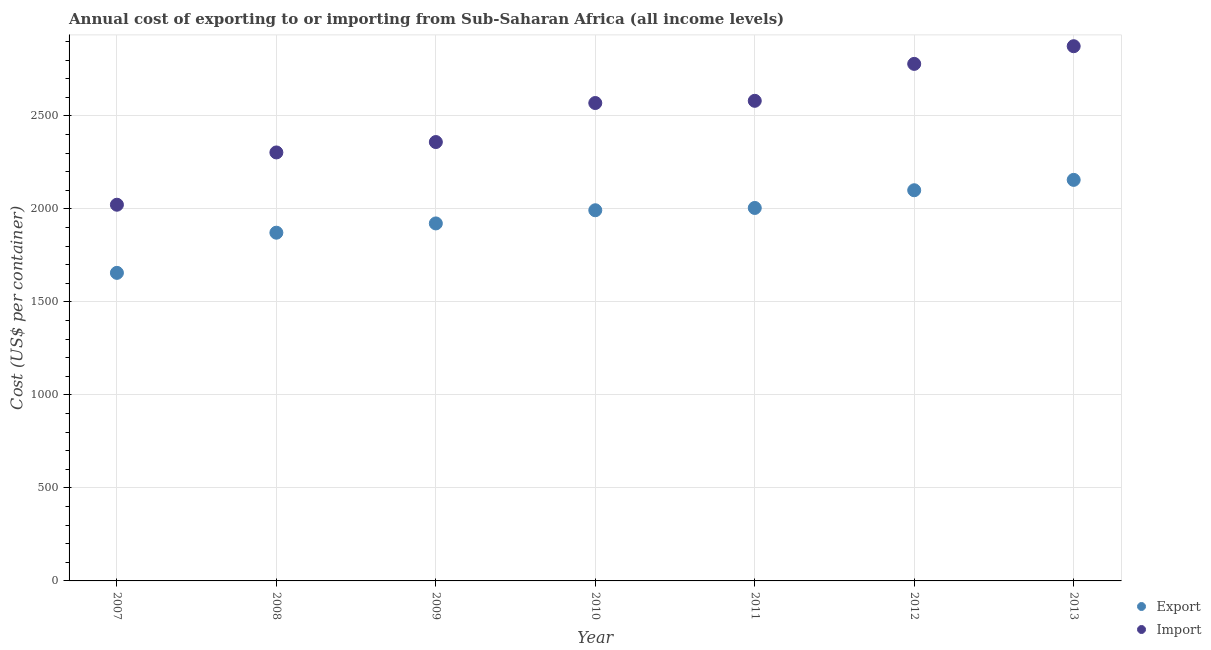Is the number of dotlines equal to the number of legend labels?
Your answer should be compact. Yes. What is the export cost in 2007?
Your response must be concise. 1655.89. Across all years, what is the maximum import cost?
Provide a succinct answer. 2874.2. Across all years, what is the minimum export cost?
Ensure brevity in your answer.  1655.89. In which year was the export cost maximum?
Offer a very short reply. 2013. What is the total import cost in the graph?
Your answer should be compact. 1.75e+04. What is the difference between the export cost in 2007 and that in 2012?
Give a very brief answer. -444.07. What is the difference between the export cost in 2007 and the import cost in 2012?
Keep it short and to the point. -1123.3. What is the average export cost per year?
Offer a very short reply. 1957.45. In the year 2012, what is the difference between the import cost and export cost?
Give a very brief answer. 679.23. What is the ratio of the import cost in 2007 to that in 2009?
Offer a terse response. 0.86. Is the export cost in 2010 less than that in 2012?
Your answer should be compact. Yes. What is the difference between the highest and the second highest export cost?
Make the answer very short. 55.74. What is the difference between the highest and the lowest import cost?
Your response must be concise. 852.07. In how many years, is the export cost greater than the average export cost taken over all years?
Offer a very short reply. 4. How many dotlines are there?
Provide a succinct answer. 2. What is the difference between two consecutive major ticks on the Y-axis?
Your answer should be compact. 500. Are the values on the major ticks of Y-axis written in scientific E-notation?
Ensure brevity in your answer.  No. How many legend labels are there?
Provide a succinct answer. 2. How are the legend labels stacked?
Provide a succinct answer. Vertical. What is the title of the graph?
Offer a very short reply. Annual cost of exporting to or importing from Sub-Saharan Africa (all income levels). What is the label or title of the Y-axis?
Your answer should be very brief. Cost (US$ per container). What is the Cost (US$ per container) in Export in 2007?
Ensure brevity in your answer.  1655.89. What is the Cost (US$ per container) in Import in 2007?
Keep it short and to the point. 2022.13. What is the Cost (US$ per container) of Export in 2008?
Make the answer very short. 1871.78. What is the Cost (US$ per container) of Import in 2008?
Provide a short and direct response. 2303.17. What is the Cost (US$ per container) of Export in 2009?
Provide a short and direct response. 1921.63. What is the Cost (US$ per container) of Import in 2009?
Ensure brevity in your answer.  2359.07. What is the Cost (US$ per container) of Export in 2010?
Your response must be concise. 1992.41. What is the Cost (US$ per container) in Import in 2010?
Offer a terse response. 2568.83. What is the Cost (US$ per container) in Export in 2011?
Your response must be concise. 2004.76. What is the Cost (US$ per container) of Import in 2011?
Offer a very short reply. 2580.65. What is the Cost (US$ per container) in Export in 2012?
Your answer should be compact. 2099.96. What is the Cost (US$ per container) of Import in 2012?
Give a very brief answer. 2779.19. What is the Cost (US$ per container) in Export in 2013?
Your answer should be compact. 2155.7. What is the Cost (US$ per container) of Import in 2013?
Ensure brevity in your answer.  2874.2. Across all years, what is the maximum Cost (US$ per container) of Export?
Give a very brief answer. 2155.7. Across all years, what is the maximum Cost (US$ per container) in Import?
Ensure brevity in your answer.  2874.2. Across all years, what is the minimum Cost (US$ per container) of Export?
Your answer should be compact. 1655.89. Across all years, what is the minimum Cost (US$ per container) of Import?
Your answer should be very brief. 2022.13. What is the total Cost (US$ per container) of Export in the graph?
Your response must be concise. 1.37e+04. What is the total Cost (US$ per container) of Import in the graph?
Your answer should be very brief. 1.75e+04. What is the difference between the Cost (US$ per container) in Export in 2007 and that in 2008?
Make the answer very short. -215.89. What is the difference between the Cost (US$ per container) in Import in 2007 and that in 2008?
Provide a short and direct response. -281.04. What is the difference between the Cost (US$ per container) in Export in 2007 and that in 2009?
Provide a short and direct response. -265.74. What is the difference between the Cost (US$ per container) of Import in 2007 and that in 2009?
Keep it short and to the point. -336.93. What is the difference between the Cost (US$ per container) of Export in 2007 and that in 2010?
Ensure brevity in your answer.  -336.52. What is the difference between the Cost (US$ per container) in Import in 2007 and that in 2010?
Give a very brief answer. -546.7. What is the difference between the Cost (US$ per container) of Export in 2007 and that in 2011?
Provide a succinct answer. -348.87. What is the difference between the Cost (US$ per container) of Import in 2007 and that in 2011?
Keep it short and to the point. -558.52. What is the difference between the Cost (US$ per container) in Export in 2007 and that in 2012?
Give a very brief answer. -444.07. What is the difference between the Cost (US$ per container) of Import in 2007 and that in 2012?
Give a very brief answer. -757.06. What is the difference between the Cost (US$ per container) in Export in 2007 and that in 2013?
Offer a very short reply. -499.81. What is the difference between the Cost (US$ per container) in Import in 2007 and that in 2013?
Your response must be concise. -852.07. What is the difference between the Cost (US$ per container) in Export in 2008 and that in 2009?
Give a very brief answer. -49.85. What is the difference between the Cost (US$ per container) in Import in 2008 and that in 2009?
Your answer should be very brief. -55.89. What is the difference between the Cost (US$ per container) in Export in 2008 and that in 2010?
Give a very brief answer. -120.63. What is the difference between the Cost (US$ per container) of Import in 2008 and that in 2010?
Offer a very short reply. -265.65. What is the difference between the Cost (US$ per container) in Export in 2008 and that in 2011?
Offer a very short reply. -132.98. What is the difference between the Cost (US$ per container) of Import in 2008 and that in 2011?
Ensure brevity in your answer.  -277.48. What is the difference between the Cost (US$ per container) of Export in 2008 and that in 2012?
Provide a short and direct response. -228.17. What is the difference between the Cost (US$ per container) of Import in 2008 and that in 2012?
Offer a very short reply. -476.02. What is the difference between the Cost (US$ per container) of Export in 2008 and that in 2013?
Provide a succinct answer. -283.92. What is the difference between the Cost (US$ per container) in Import in 2008 and that in 2013?
Your answer should be compact. -571.03. What is the difference between the Cost (US$ per container) of Export in 2009 and that in 2010?
Give a very brief answer. -70.78. What is the difference between the Cost (US$ per container) of Import in 2009 and that in 2010?
Offer a very short reply. -209.76. What is the difference between the Cost (US$ per container) of Export in 2009 and that in 2011?
Your answer should be compact. -83.13. What is the difference between the Cost (US$ per container) of Import in 2009 and that in 2011?
Provide a short and direct response. -221.59. What is the difference between the Cost (US$ per container) of Export in 2009 and that in 2012?
Make the answer very short. -178.33. What is the difference between the Cost (US$ per container) of Import in 2009 and that in 2012?
Your response must be concise. -420.13. What is the difference between the Cost (US$ per container) of Export in 2009 and that in 2013?
Offer a terse response. -234.07. What is the difference between the Cost (US$ per container) in Import in 2009 and that in 2013?
Give a very brief answer. -515.14. What is the difference between the Cost (US$ per container) of Export in 2010 and that in 2011?
Give a very brief answer. -12.35. What is the difference between the Cost (US$ per container) in Import in 2010 and that in 2011?
Keep it short and to the point. -11.83. What is the difference between the Cost (US$ per container) in Export in 2010 and that in 2012?
Your answer should be very brief. -107.54. What is the difference between the Cost (US$ per container) of Import in 2010 and that in 2012?
Offer a very short reply. -210.37. What is the difference between the Cost (US$ per container) of Export in 2010 and that in 2013?
Provide a short and direct response. -163.29. What is the difference between the Cost (US$ per container) of Import in 2010 and that in 2013?
Provide a succinct answer. -305.38. What is the difference between the Cost (US$ per container) of Export in 2011 and that in 2012?
Offer a terse response. -95.2. What is the difference between the Cost (US$ per container) of Import in 2011 and that in 2012?
Keep it short and to the point. -198.54. What is the difference between the Cost (US$ per container) of Export in 2011 and that in 2013?
Your answer should be compact. -150.94. What is the difference between the Cost (US$ per container) of Import in 2011 and that in 2013?
Make the answer very short. -293.55. What is the difference between the Cost (US$ per container) of Export in 2012 and that in 2013?
Your answer should be very brief. -55.74. What is the difference between the Cost (US$ per container) of Import in 2012 and that in 2013?
Your answer should be very brief. -95.01. What is the difference between the Cost (US$ per container) of Export in 2007 and the Cost (US$ per container) of Import in 2008?
Your answer should be very brief. -647.28. What is the difference between the Cost (US$ per container) of Export in 2007 and the Cost (US$ per container) of Import in 2009?
Your response must be concise. -703.17. What is the difference between the Cost (US$ per container) in Export in 2007 and the Cost (US$ per container) in Import in 2010?
Keep it short and to the point. -912.93. What is the difference between the Cost (US$ per container) of Export in 2007 and the Cost (US$ per container) of Import in 2011?
Provide a short and direct response. -924.76. What is the difference between the Cost (US$ per container) in Export in 2007 and the Cost (US$ per container) in Import in 2012?
Your answer should be compact. -1123.3. What is the difference between the Cost (US$ per container) in Export in 2007 and the Cost (US$ per container) in Import in 2013?
Give a very brief answer. -1218.31. What is the difference between the Cost (US$ per container) in Export in 2008 and the Cost (US$ per container) in Import in 2009?
Offer a terse response. -487.28. What is the difference between the Cost (US$ per container) of Export in 2008 and the Cost (US$ per container) of Import in 2010?
Offer a very short reply. -697.04. What is the difference between the Cost (US$ per container) of Export in 2008 and the Cost (US$ per container) of Import in 2011?
Your response must be concise. -708.87. What is the difference between the Cost (US$ per container) in Export in 2008 and the Cost (US$ per container) in Import in 2012?
Make the answer very short. -907.41. What is the difference between the Cost (US$ per container) in Export in 2008 and the Cost (US$ per container) in Import in 2013?
Your answer should be very brief. -1002.42. What is the difference between the Cost (US$ per container) of Export in 2009 and the Cost (US$ per container) of Import in 2010?
Your answer should be very brief. -647.2. What is the difference between the Cost (US$ per container) in Export in 2009 and the Cost (US$ per container) in Import in 2011?
Your answer should be very brief. -659.02. What is the difference between the Cost (US$ per container) of Export in 2009 and the Cost (US$ per container) of Import in 2012?
Your response must be concise. -857.56. What is the difference between the Cost (US$ per container) in Export in 2009 and the Cost (US$ per container) in Import in 2013?
Ensure brevity in your answer.  -952.57. What is the difference between the Cost (US$ per container) of Export in 2010 and the Cost (US$ per container) of Import in 2011?
Make the answer very short. -588.24. What is the difference between the Cost (US$ per container) of Export in 2010 and the Cost (US$ per container) of Import in 2012?
Keep it short and to the point. -786.78. What is the difference between the Cost (US$ per container) in Export in 2010 and the Cost (US$ per container) in Import in 2013?
Make the answer very short. -881.79. What is the difference between the Cost (US$ per container) of Export in 2011 and the Cost (US$ per container) of Import in 2012?
Offer a very short reply. -774.43. What is the difference between the Cost (US$ per container) in Export in 2011 and the Cost (US$ per container) in Import in 2013?
Give a very brief answer. -869.44. What is the difference between the Cost (US$ per container) in Export in 2012 and the Cost (US$ per container) in Import in 2013?
Your answer should be compact. -774.24. What is the average Cost (US$ per container) in Export per year?
Your answer should be very brief. 1957.45. What is the average Cost (US$ per container) in Import per year?
Keep it short and to the point. 2498.18. In the year 2007, what is the difference between the Cost (US$ per container) of Export and Cost (US$ per container) of Import?
Your response must be concise. -366.24. In the year 2008, what is the difference between the Cost (US$ per container) of Export and Cost (US$ per container) of Import?
Your answer should be very brief. -431.39. In the year 2009, what is the difference between the Cost (US$ per container) in Export and Cost (US$ per container) in Import?
Keep it short and to the point. -437.43. In the year 2010, what is the difference between the Cost (US$ per container) in Export and Cost (US$ per container) in Import?
Provide a succinct answer. -576.41. In the year 2011, what is the difference between the Cost (US$ per container) in Export and Cost (US$ per container) in Import?
Your answer should be very brief. -575.89. In the year 2012, what is the difference between the Cost (US$ per container) of Export and Cost (US$ per container) of Import?
Make the answer very short. -679.23. In the year 2013, what is the difference between the Cost (US$ per container) of Export and Cost (US$ per container) of Import?
Offer a terse response. -718.5. What is the ratio of the Cost (US$ per container) of Export in 2007 to that in 2008?
Keep it short and to the point. 0.88. What is the ratio of the Cost (US$ per container) of Import in 2007 to that in 2008?
Give a very brief answer. 0.88. What is the ratio of the Cost (US$ per container) in Export in 2007 to that in 2009?
Offer a terse response. 0.86. What is the ratio of the Cost (US$ per container) of Import in 2007 to that in 2009?
Provide a succinct answer. 0.86. What is the ratio of the Cost (US$ per container) of Export in 2007 to that in 2010?
Your response must be concise. 0.83. What is the ratio of the Cost (US$ per container) in Import in 2007 to that in 2010?
Ensure brevity in your answer.  0.79. What is the ratio of the Cost (US$ per container) in Export in 2007 to that in 2011?
Offer a very short reply. 0.83. What is the ratio of the Cost (US$ per container) in Import in 2007 to that in 2011?
Keep it short and to the point. 0.78. What is the ratio of the Cost (US$ per container) of Export in 2007 to that in 2012?
Your answer should be very brief. 0.79. What is the ratio of the Cost (US$ per container) in Import in 2007 to that in 2012?
Give a very brief answer. 0.73. What is the ratio of the Cost (US$ per container) of Export in 2007 to that in 2013?
Provide a short and direct response. 0.77. What is the ratio of the Cost (US$ per container) of Import in 2007 to that in 2013?
Keep it short and to the point. 0.7. What is the ratio of the Cost (US$ per container) in Export in 2008 to that in 2009?
Provide a succinct answer. 0.97. What is the ratio of the Cost (US$ per container) of Import in 2008 to that in 2009?
Offer a very short reply. 0.98. What is the ratio of the Cost (US$ per container) in Export in 2008 to that in 2010?
Offer a very short reply. 0.94. What is the ratio of the Cost (US$ per container) in Import in 2008 to that in 2010?
Provide a succinct answer. 0.9. What is the ratio of the Cost (US$ per container) of Export in 2008 to that in 2011?
Provide a short and direct response. 0.93. What is the ratio of the Cost (US$ per container) of Import in 2008 to that in 2011?
Your answer should be compact. 0.89. What is the ratio of the Cost (US$ per container) in Export in 2008 to that in 2012?
Ensure brevity in your answer.  0.89. What is the ratio of the Cost (US$ per container) of Import in 2008 to that in 2012?
Provide a short and direct response. 0.83. What is the ratio of the Cost (US$ per container) of Export in 2008 to that in 2013?
Your answer should be very brief. 0.87. What is the ratio of the Cost (US$ per container) of Import in 2008 to that in 2013?
Your answer should be compact. 0.8. What is the ratio of the Cost (US$ per container) in Export in 2009 to that in 2010?
Provide a short and direct response. 0.96. What is the ratio of the Cost (US$ per container) of Import in 2009 to that in 2010?
Provide a short and direct response. 0.92. What is the ratio of the Cost (US$ per container) of Export in 2009 to that in 2011?
Offer a very short reply. 0.96. What is the ratio of the Cost (US$ per container) of Import in 2009 to that in 2011?
Give a very brief answer. 0.91. What is the ratio of the Cost (US$ per container) of Export in 2009 to that in 2012?
Keep it short and to the point. 0.92. What is the ratio of the Cost (US$ per container) of Import in 2009 to that in 2012?
Give a very brief answer. 0.85. What is the ratio of the Cost (US$ per container) in Export in 2009 to that in 2013?
Ensure brevity in your answer.  0.89. What is the ratio of the Cost (US$ per container) of Import in 2009 to that in 2013?
Make the answer very short. 0.82. What is the ratio of the Cost (US$ per container) of Export in 2010 to that in 2012?
Give a very brief answer. 0.95. What is the ratio of the Cost (US$ per container) of Import in 2010 to that in 2012?
Offer a terse response. 0.92. What is the ratio of the Cost (US$ per container) in Export in 2010 to that in 2013?
Your answer should be compact. 0.92. What is the ratio of the Cost (US$ per container) in Import in 2010 to that in 2013?
Give a very brief answer. 0.89. What is the ratio of the Cost (US$ per container) of Export in 2011 to that in 2012?
Ensure brevity in your answer.  0.95. What is the ratio of the Cost (US$ per container) of Export in 2011 to that in 2013?
Offer a very short reply. 0.93. What is the ratio of the Cost (US$ per container) of Import in 2011 to that in 2013?
Your response must be concise. 0.9. What is the ratio of the Cost (US$ per container) in Export in 2012 to that in 2013?
Provide a short and direct response. 0.97. What is the ratio of the Cost (US$ per container) of Import in 2012 to that in 2013?
Your answer should be compact. 0.97. What is the difference between the highest and the second highest Cost (US$ per container) of Export?
Give a very brief answer. 55.74. What is the difference between the highest and the second highest Cost (US$ per container) of Import?
Your response must be concise. 95.01. What is the difference between the highest and the lowest Cost (US$ per container) in Export?
Offer a very short reply. 499.81. What is the difference between the highest and the lowest Cost (US$ per container) in Import?
Provide a short and direct response. 852.07. 